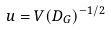<formula> <loc_0><loc_0><loc_500><loc_500>u = V ( D _ { G } ) ^ { - 1 / 2 }</formula> 